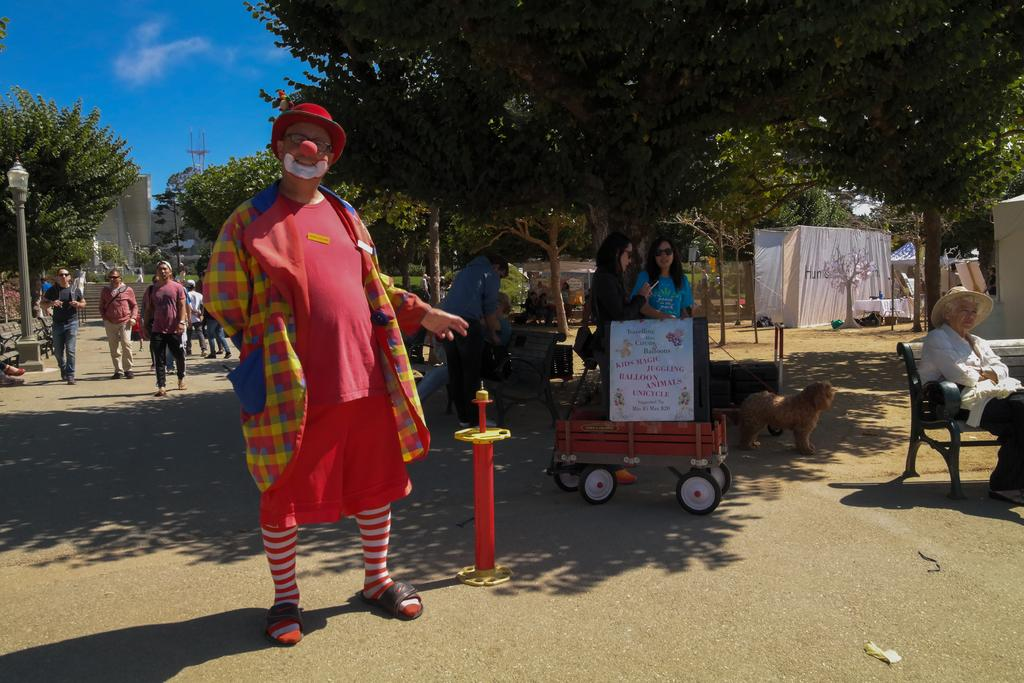What is happening in the foreground of the image? There is a group of people standing in the road. What can be seen in the background of the image? There is a tree, a tent, a street light, a dog, a building, and the sky visible in the background. How many structures are present in the background? There are at least two structures present in the background: a tent and a building. What type of frame is holding the things together in the image? There is no frame present in the image, and the term "things" is not specific enough to identify any objects that might be held together. Can you tell me how many needles are in the image? There are no needles present in the image. 